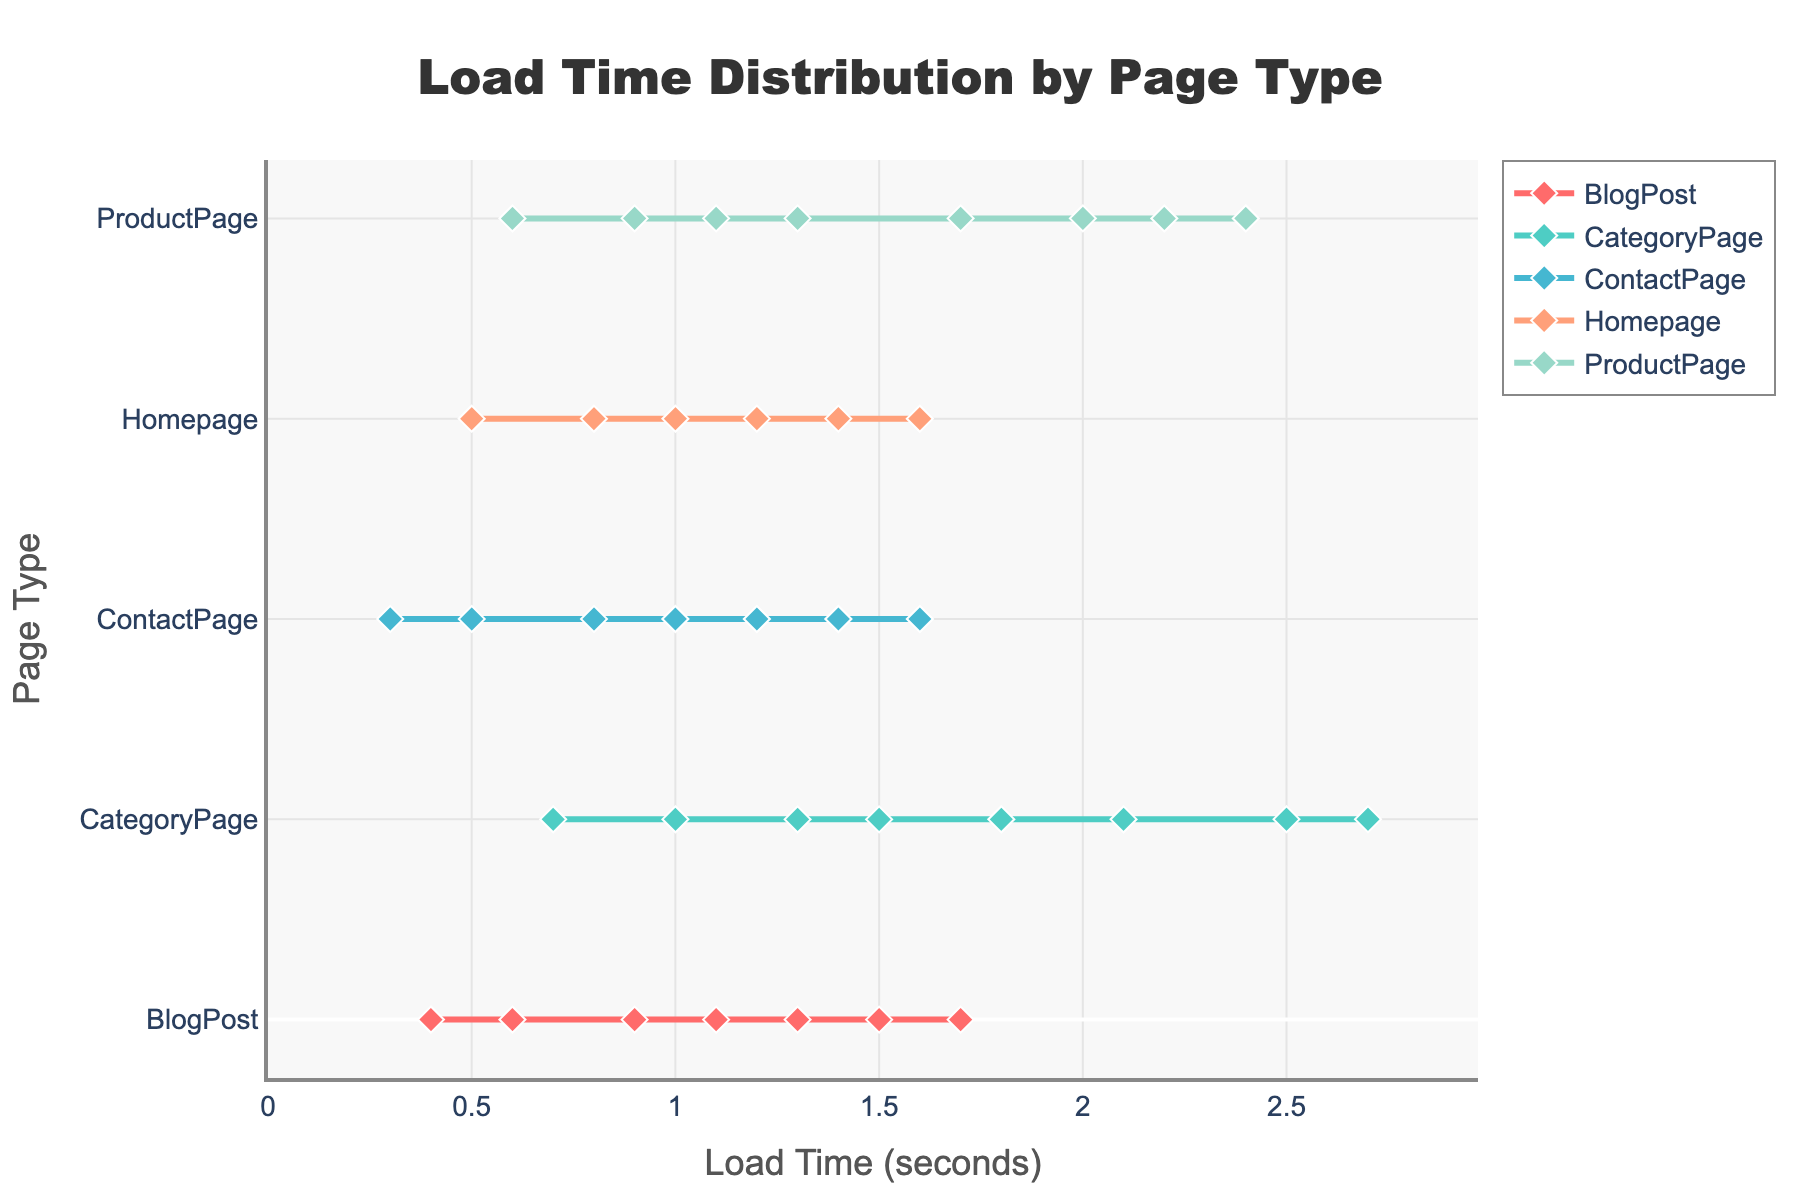What is the title of the plot? The title is located at the top center of the plot and is prominently displayed. It reads 'Load Time Distribution by Page Type'.
Answer: Load Time Distribution by Page Type What is the range of the x-axis? The x-axis represents Load Time (seconds) with a range from 0 to approximately 2.75 seconds, as indicated by the axis labels and the stated range in the axis customization.
Answer: 0 to 2.75 seconds Which Page Type has the lowest minimum load time? The 'ContactPage' has the lowest minimum load time at 0.3 seconds, as shown by the first data point on the x-axis for this page type.
Answer: ContactPage How many different Page Types are there? There are 5 different Page Types, as indicated by the distinct y-axis labels in the plot: Homepage, ProductPage, CategoryPage, BlogPost, and ContactPage.
Answer: 5 What is the maximum load time for the 'ProductPage'? The maximum load time for 'ProductPage' is 2.4 seconds, as indicated by the highest x-axis data point for this Page Type.
Answer: 2.4 seconds Which Page Type exhibits the most extended range in load times? The 'CategoryPage' exhibits the most extended range, from 0.7 up to 2.7 seconds, which spans 2 seconds.
Answer: CategoryPage Compare the load time distribution for 'Homepage' and 'BlogPost'. Which Page Type generally has faster load times? Both 'Homepage' and 'BlogPost' have similar minimum load times around 0.5 and 0.4 seconds respectively, but 'Homepage' generally exhibits slightly faster load times as it remains under 1.6 seconds while 'BlogPost' reaches up to 1.7 seconds.
Answer: Homepage What color represents the 'CategoryPage' in the plot? Each Page Type is represented by a distinct color. The 'CategoryPage' is represented by a shade of light blue/turquoise.
Answer: Turquoise Calculate the average load time for 'BlogPost'. To find the average load time for 'BlogPost', add all the load times together (0.4 + 0.6 + 0.9 + 1.1 + 1.3 + 1.5 + 1.7) and divide by the number of data points (7). Average = (0.4 + 0.6 + 0.9 + 1.1 + 1.3 + 1.5 + 1.7)/7 = 1.07 seconds.
Answer: 1.07 seconds Which Page Type has the most clustered load times near the start of the x-axis? 'ContactPage' load times are more clustered near the start with load times spanning only from 0.3 to 1.6 seconds, compared to other Page Types which span larger ranges.
Answer: ContactPage 